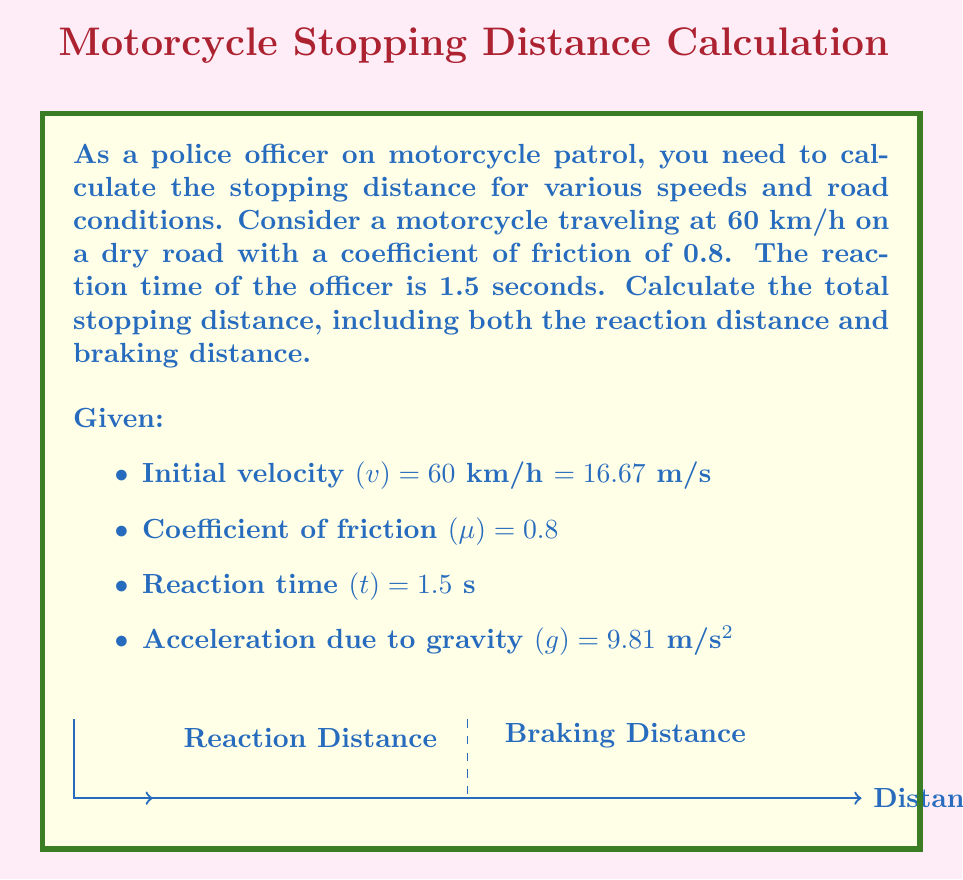Show me your answer to this math problem. To calculate the total stopping distance, we need to determine both the reaction distance and the braking distance.

1. Reaction Distance:
   The reaction distance is the distance traveled during the officer's reaction time.
   $$d_r = v \cdot t$$
   $$d_r = 16.67 \text{ m/s} \cdot 1.5 \text{ s} = 25 \text{ m}$$

2. Braking Distance:
   The braking distance is calculated using the work-energy theorem. The initial kinetic energy is converted to work done by friction.
   $$\frac{1}{2}mv^2 = \mu mg d_b$$
   
   Where $m$ is the mass of the motorcycle and rider, $g$ is the acceleration due to gravity, and $d_b$ is the braking distance.
   
   Simplifying and solving for $d_b$:
   $$d_b = \frac{v^2}{2\mu g}$$
   $$d_b = \frac{(16.67 \text{ m/s})^2}{2 \cdot 0.8 \cdot 9.81 \text{ m/s}^2} = 17.69 \text{ m}$$

3. Total Stopping Distance:
   The total stopping distance is the sum of the reaction distance and braking distance.
   $$d_{\text{total}} = d_r + d_b$$
   $$d_{\text{total}} = 25 \text{ m} + 17.69 \text{ m} = 42.69 \text{ m}$$
Answer: 42.69 m 